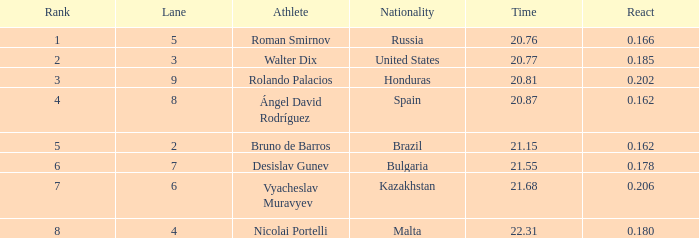What's Bulgaria's lane with a time more than 21.55? None. 